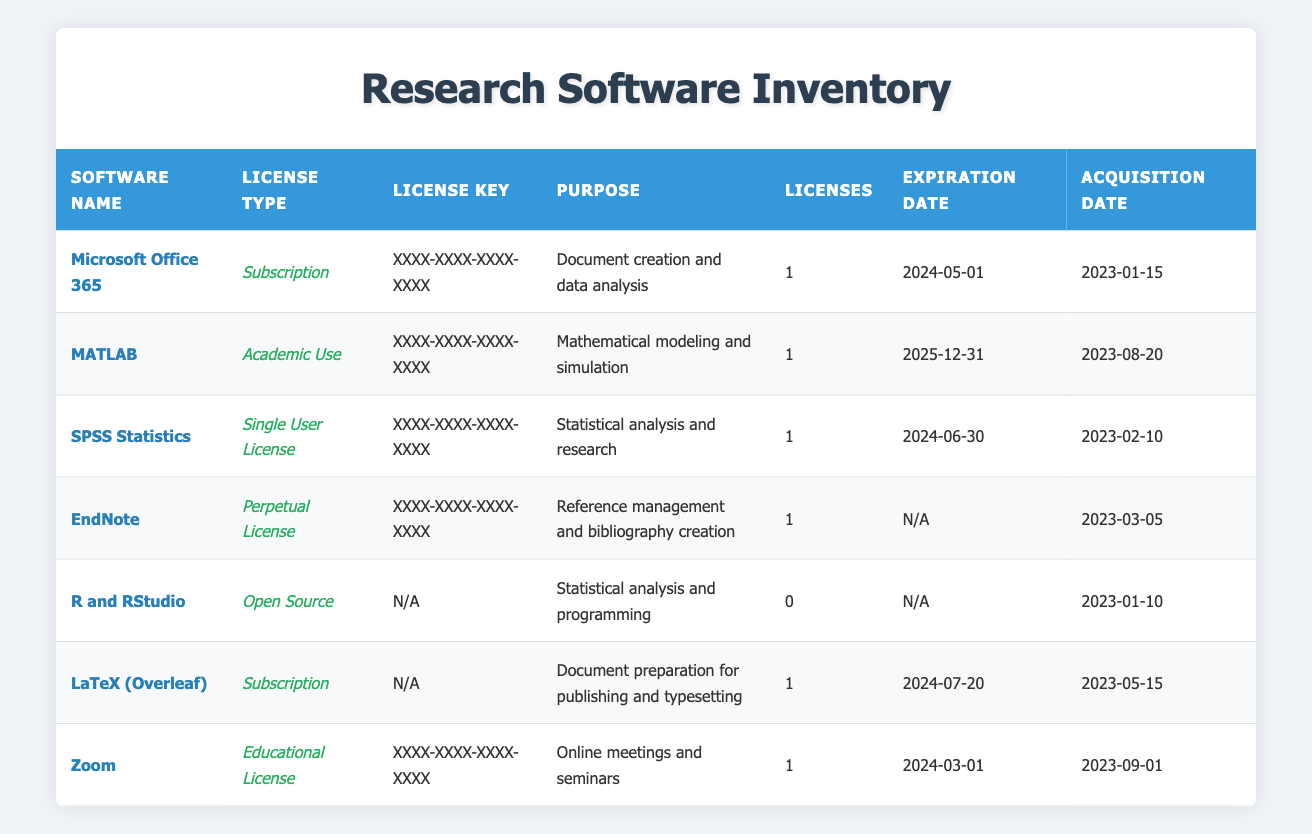What's the purpose of MATLAB? By looking at the row for MATLAB, I can see that the purpose specified is "Mathematical modeling and simulation."
Answer: Mathematical modeling and simulation How many total licenses are available for document preparation tools? The relevant entries are Microsoft Office 365 (1 license) and LaTeX (Overleaf) (1 license). Adding these values gives a total of 1 + 1 = 2 licenses.
Answer: 2 Is the license for SPSS Statistics a perpetual license? The entry for SPSS Statistics shows that it has a "Single User License," which is not a perpetual license. Thus, the fact is false.
Answer: No Which software has the latest expiration date? Checking the expiration dates, MATLAB expires on 2025-12-31, while all others either expire earlier or are perpetual. Hence, MATLAB has the latest expiration date.
Answer: MATLAB What is the average number of licenses across all software listed? The total number of licenses is 1 (Office 365) + 1 (MATLAB) + 1 (SPSS) + 1 (EndNote) + 0 (R and RStudio) + 1 (LaTeX) + 1 (Zoom) = 5 licenses. There are 7 software entries. Therefore, the average is 5/7 = 0.71 (rounded to two decimals).
Answer: 0.71 Does any software listed have a license key labeled as "N/A"? Looking through the table, I find that R and RStudio and LaTeX (Overleaf) have their license keys listed as "N/A." This confirms the fact to be true.
Answer: Yes Which software acquisition date is the most recent? By reviewing the acquisition dates, I note that the date for Zoom is 2023-09-01, which is more recent than any other software.
Answer: Zoom How long is the license for Microsoft Office 365 valid until? The expiration date listed for Microsoft Office 365 is 2024-05-01, meaning the license is valid until that date.
Answer: Until 2024-05-01 